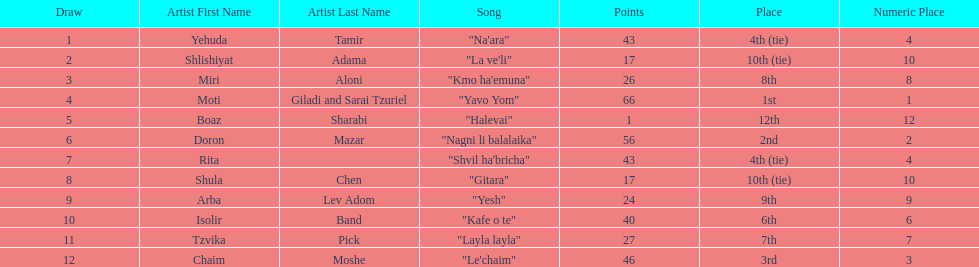What artist received the least amount of points in the competition? Boaz Sharabi. 